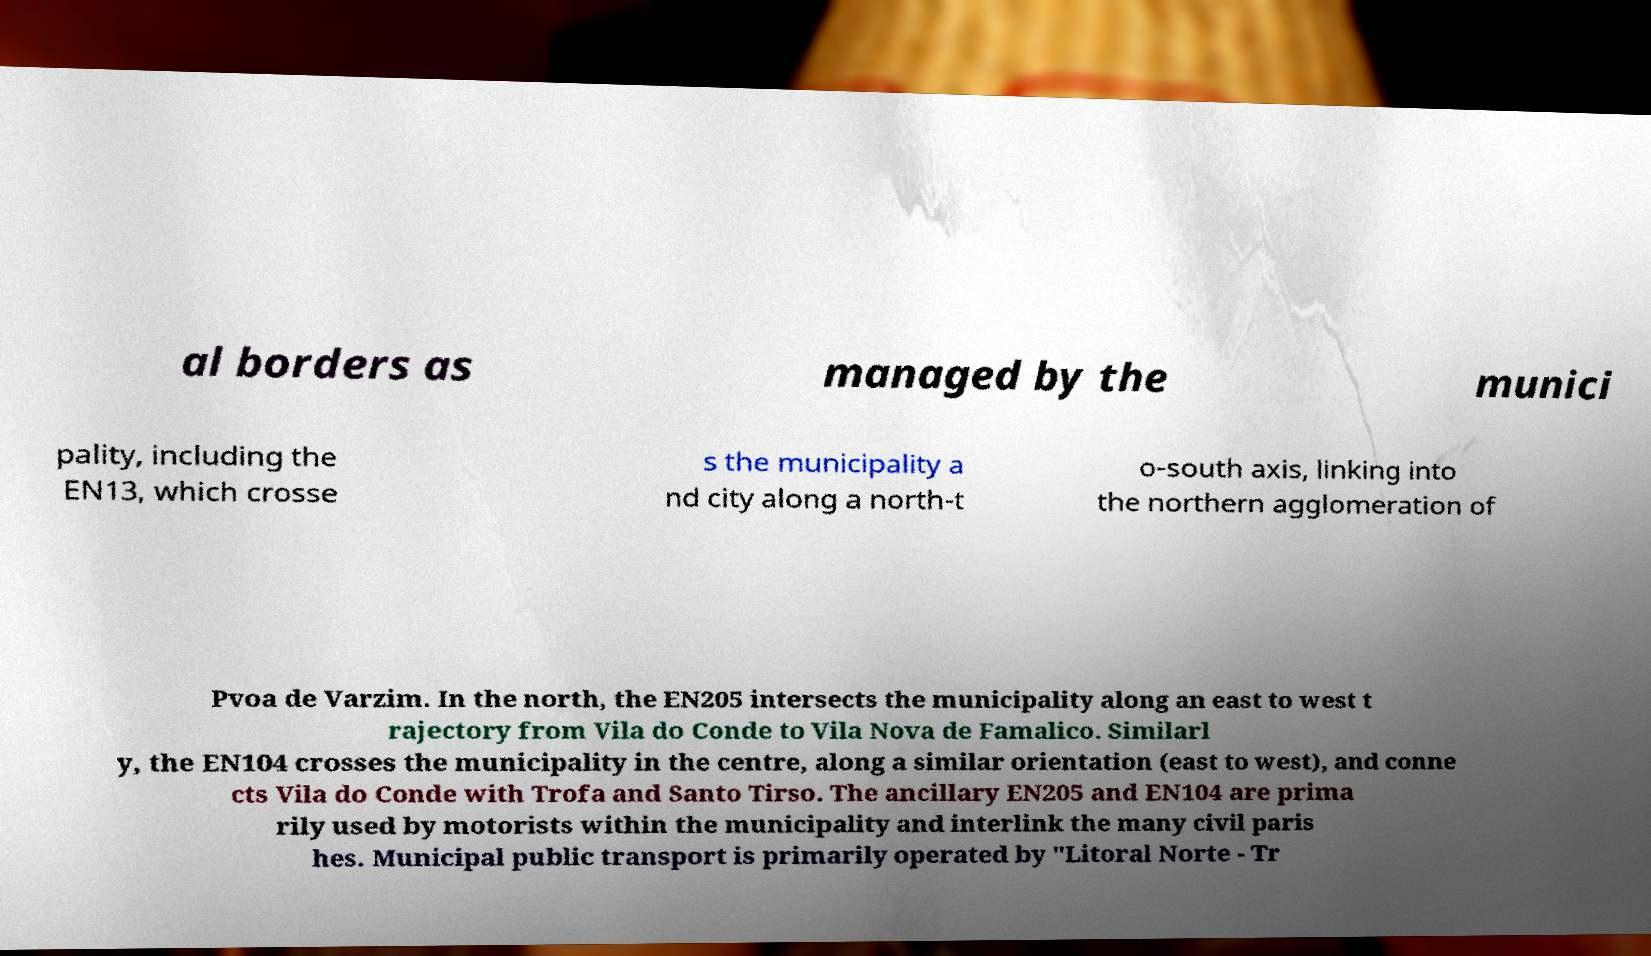Can you accurately transcribe the text from the provided image for me? al borders as managed by the munici pality, including the EN13, which crosse s the municipality a nd city along a north-t o-south axis, linking into the northern agglomeration of Pvoa de Varzim. In the north, the EN205 intersects the municipality along an east to west t rajectory from Vila do Conde to Vila Nova de Famalico. Similarl y, the EN104 crosses the municipality in the centre, along a similar orientation (east to west), and conne cts Vila do Conde with Trofa and Santo Tirso. The ancillary EN205 and EN104 are prima rily used by motorists within the municipality and interlink the many civil paris hes. Municipal public transport is primarily operated by "Litoral Norte - Tr 